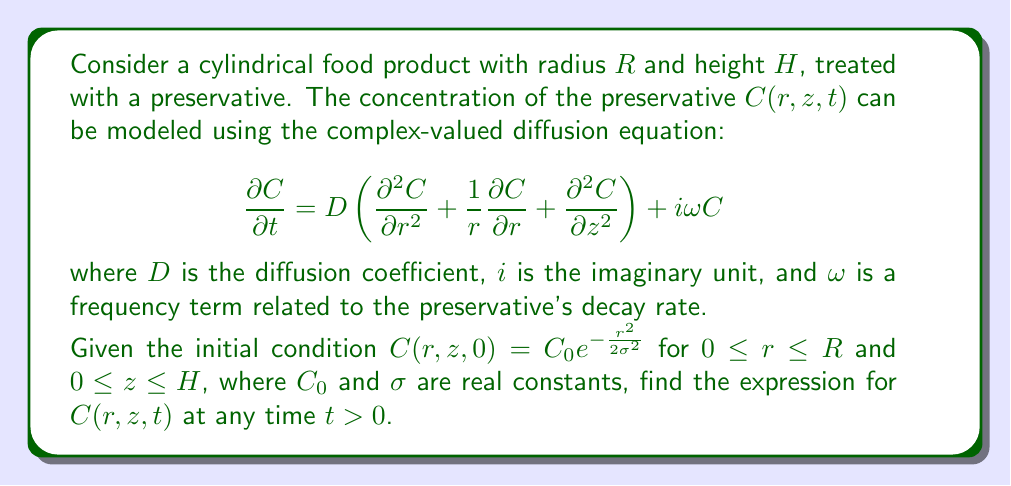What is the answer to this math problem? To solve this problem, we'll use the method of separation of variables and Fourier-Bessel series. Let's break it down step by step:

1) Assume the solution has the form:
   $C(r,z,t) = R(r)Z(z)T(t)$

2) Substituting this into the original equation:
   $$R(r)Z(z)\frac{dT}{dt} = D\left(Z(z)T(t)\frac{d^2R}{dr^2} + \frac{Z(z)T(t)}{r}\frac{dR}{dr} + R(r)T(t)\frac{d^2Z}{dz^2}\right) + i\omega R(r)Z(z)T(t)$$

3) Dividing by $R(r)Z(z)T(t)$:
   $$\frac{1}{T}\frac{dT}{dt} = D\left(\frac{1}{R}\frac{d^2R}{dr^2} + \frac{1}{rR}\frac{dR}{dr} + \frac{1}{Z}\frac{d^2Z}{dz^2}\right) + i\omega$$

4) The z-dependent part can be separated:
   $$\frac{1}{Z}\frac{d^2Z}{dz^2} = -k^2$$
   where $k$ is a separation constant. The solution is:
   $Z(z) = A\cos(kz) + B\sin(kz)$

5) For the radial part:
   $$\frac{1}{R}\frac{d^2R}{dr^2} + \frac{1}{rR}\frac{dR}{dr} = -\lambda^2$$
   where $\lambda^2 = \frac{k^2D - i\omega}{D}$. This is Bessel's equation, with solution:
   $R(r) = J_0(\lambda r)$, where $J_0$ is the Bessel function of the first kind of order zero.

6) For the time part:
   $$\frac{1}{T}\frac{dT}{dt} = -D\lambda^2$$
   with solution:
   $T(t) = e^{-D\lambda^2 t}$

7) The general solution is:
   $$C(r,z,t) = \sum_{n=1}^{\infty}\sum_{m=1}^{\infty} A_{nm}J_0(\lambda_n r)\cos(k_m z)e^{-D\lambda_n^2 t}$$
   where $\lambda_n$ are the roots of $J_0(\lambda R) = 0$, and $k_m = \frac{m\pi}{H}$.

8) To satisfy the initial condition, we need to expand $C_0e^{-\frac{r^2}{2\sigma^2}}$ in terms of $J_0(\lambda_n r)\cos(k_m z)$:
   $$A_{nm} = \frac{2}{H[J_1(\lambda_n R)]^2}\int_0^R rJ_0(\lambda_n r)e^{-\frac{r^2}{2\sigma^2}}dr \cdot \int_0^H \cos(k_m z)dz$$

9) Evaluating these integrals:
   $$A_{nm} = \frac{2C_0\sigma^2}{H[J_1(\lambda_n R)]^2}e^{-\frac{\lambda_n^2\sigma^2}{2}}[1-(-1)^m]$$

Therefore, the final solution is:

$$C(r,z,t) = \frac{2C_0\sigma^2}{H}\sum_{n=1}^{\infty}\sum_{m=1}^{\infty} \frac{e^{-\frac{\lambda_n^2\sigma^2}{2}}[1-(-1)^m]}{[J_1(\lambda_n R)]^2}J_0(\lambda_n r)\cos(k_m z)e^{-D\lambda_n^2 t}$$

where $\lambda_n$ are the roots of $J_0(\lambda R) = 0$, and $k_m = \frac{m\pi}{H}$.
Answer: $$C(r,z,t) = \frac{2C_0\sigma^2}{H}\sum_{n=1}^{\infty}\sum_{m=1}^{\infty} \frac{e^{-\frac{\lambda_n^2\sigma^2}{2}}[1-(-1)^m]}{[J_1(\lambda_n R)]^2}J_0(\lambda_n r)\cos(k_m z)e^{-D\lambda_n^2 t}$$
where $\lambda_n$ are the roots of $J_0(\lambda R) = 0$, and $k_m = \frac{m\pi}{H}$. 